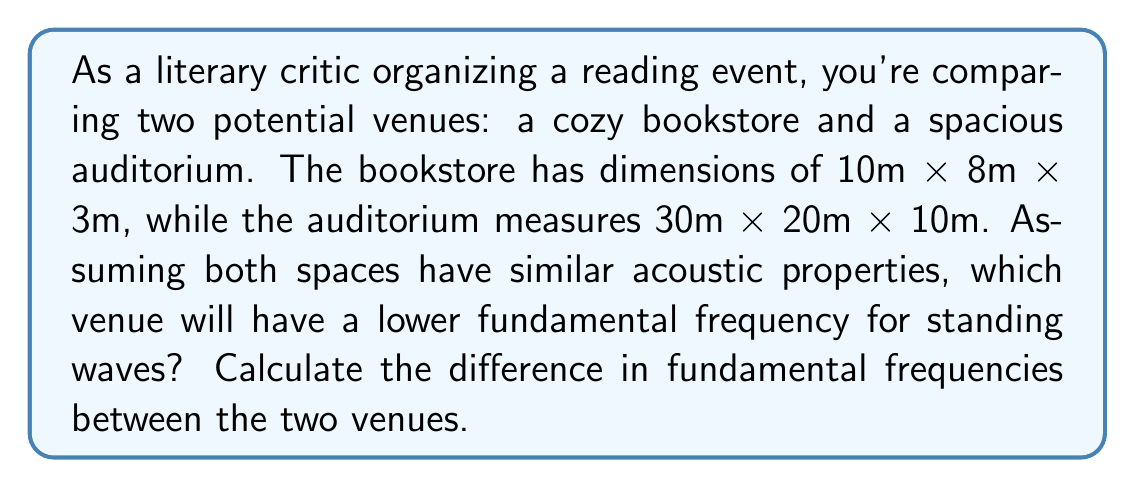Provide a solution to this math problem. To solve this problem, we'll use the wave equation for standing waves in a rectangular room. The fundamental frequency for a room with dimensions $L_x$, $L_y$, and $L_z$ is given by:

$$ f = \frac{c}{2} \sqrt{\left(\frac{1}{L_x}\right)^2 + \left(\frac{1}{L_y}\right)^2 + \left(\frac{1}{L_z}\right)^2} $$

Where $c$ is the speed of sound in air (approximately 343 m/s at room temperature).

Step 1: Calculate the fundamental frequency for the bookstore.
$$ f_{bookstore} = \frac{343}{2} \sqrt{\left(\frac{1}{10}\right)^2 + \left(\frac{1}{8}\right)^2 + \left(\frac{1}{3}\right)^2} $$
$$ f_{bookstore} \approx 57.17 \text{ Hz} $$

Step 2: Calculate the fundamental frequency for the auditorium.
$$ f_{auditorium} = \frac{343}{2} \sqrt{\left(\frac{1}{30}\right)^2 + \left(\frac{1}{20}\right)^2 + \left(\frac{1}{10}\right)^2} $$
$$ f_{auditorium} \approx 17.15 \text{ Hz} $$

Step 3: Determine which venue has the lower fundamental frequency.
The auditorium has a lower fundamental frequency (17.15 Hz) compared to the bookstore (57.17 Hz).

Step 4: Calculate the difference in fundamental frequencies.
$$ \Delta f = f_{bookstore} - f_{auditorium} $$
$$ \Delta f = 57.17 \text{ Hz} - 17.15 \text{ Hz} = 40.02 \text{ Hz} $$
Answer: The auditorium; 40.02 Hz 